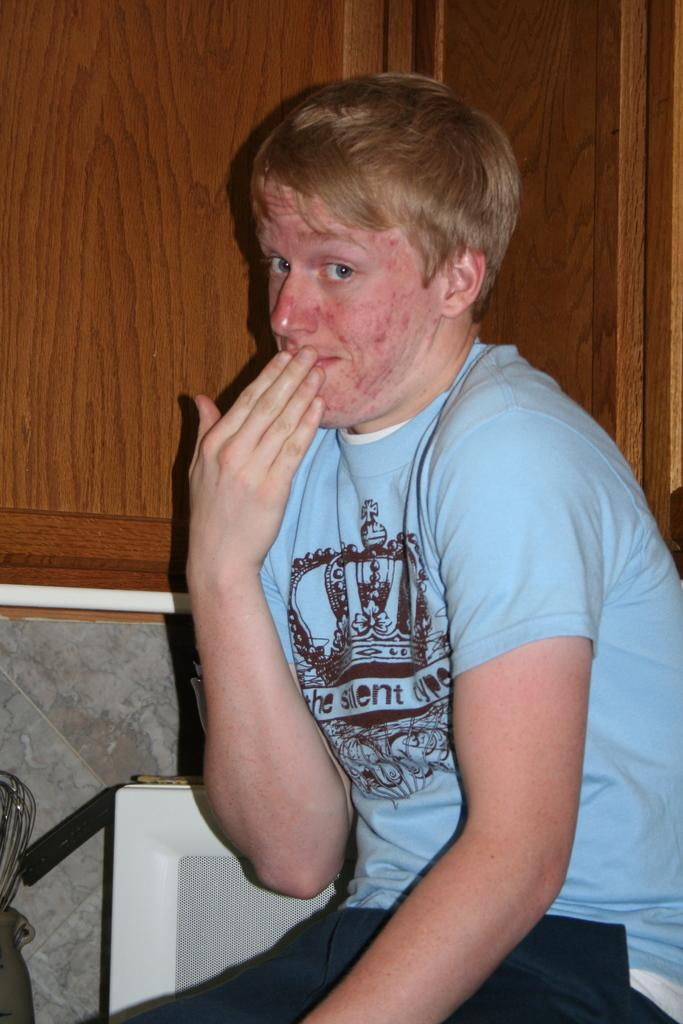Who is the main subject in the image? There is a boy in the image. What is the boy wearing? The boy is wearing a blue t-shirt. Where is the boy positioned in the image? The boy is sitting in the front. What is the boy doing in the image? The boy is posing for the camera. What can be seen in the background of the image? There is a wooden cabinet door in the background of the image. What type of tank can be seen in the image? There is no tank present in the image; it features a boy sitting in the front and posing for the camera. Who is the guide in the image? There is no guide present in the image; it only features a boy sitting in the front and posing for the camera. 